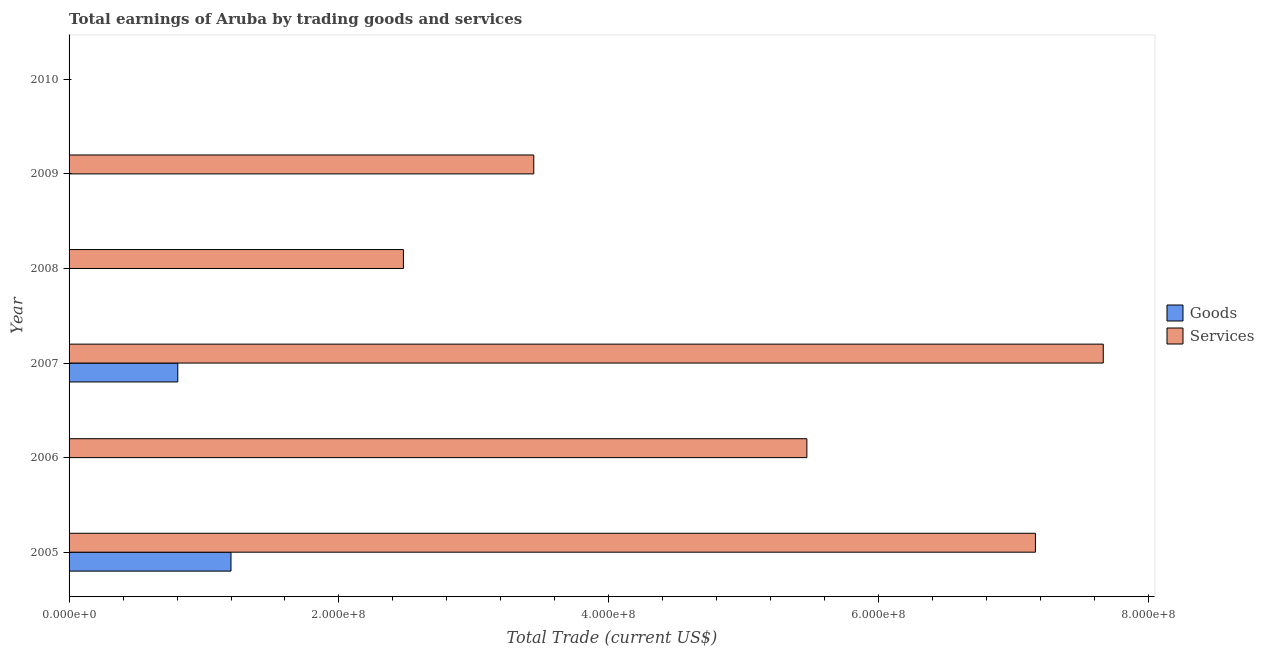Are the number of bars on each tick of the Y-axis equal?
Your answer should be compact. No. How many bars are there on the 1st tick from the bottom?
Your answer should be compact. 2. What is the label of the 4th group of bars from the top?
Your answer should be very brief. 2007. In how many cases, is the number of bars for a given year not equal to the number of legend labels?
Provide a short and direct response. 4. What is the amount earned by trading services in 2008?
Your answer should be compact. 2.48e+08. Across all years, what is the maximum amount earned by trading goods?
Offer a very short reply. 1.20e+08. Across all years, what is the minimum amount earned by trading services?
Your answer should be very brief. 0. What is the total amount earned by trading goods in the graph?
Make the answer very short. 2.01e+08. What is the difference between the amount earned by trading services in 2006 and that in 2009?
Offer a very short reply. 2.02e+08. What is the difference between the amount earned by trading goods in 2009 and the amount earned by trading services in 2006?
Give a very brief answer. -5.47e+08. What is the average amount earned by trading goods per year?
Your answer should be compact. 3.34e+07. In the year 2005, what is the difference between the amount earned by trading goods and amount earned by trading services?
Offer a terse response. -5.96e+08. In how many years, is the amount earned by trading goods greater than 240000000 US$?
Give a very brief answer. 0. What is the ratio of the amount earned by trading services in 2007 to that in 2009?
Provide a succinct answer. 2.23. Is the amount earned by trading services in 2007 less than that in 2008?
Give a very brief answer. No. What is the difference between the highest and the second highest amount earned by trading services?
Offer a very short reply. 5.03e+07. What is the difference between the highest and the lowest amount earned by trading goods?
Provide a short and direct response. 1.20e+08. In how many years, is the amount earned by trading services greater than the average amount earned by trading services taken over all years?
Ensure brevity in your answer.  3. Is the sum of the amount earned by trading services in 2006 and 2008 greater than the maximum amount earned by trading goods across all years?
Your answer should be compact. Yes. How many years are there in the graph?
Keep it short and to the point. 6. Are the values on the major ticks of X-axis written in scientific E-notation?
Provide a short and direct response. Yes. Where does the legend appear in the graph?
Give a very brief answer. Center right. What is the title of the graph?
Give a very brief answer. Total earnings of Aruba by trading goods and services. What is the label or title of the X-axis?
Your answer should be compact. Total Trade (current US$). What is the Total Trade (current US$) in Goods in 2005?
Make the answer very short. 1.20e+08. What is the Total Trade (current US$) of Services in 2005?
Your answer should be compact. 7.16e+08. What is the Total Trade (current US$) in Services in 2006?
Provide a succinct answer. 5.47e+08. What is the Total Trade (current US$) in Goods in 2007?
Your answer should be compact. 8.06e+07. What is the Total Trade (current US$) in Services in 2007?
Your answer should be compact. 7.66e+08. What is the Total Trade (current US$) in Goods in 2008?
Give a very brief answer. 0. What is the Total Trade (current US$) of Services in 2008?
Offer a terse response. 2.48e+08. What is the Total Trade (current US$) of Services in 2009?
Offer a very short reply. 3.44e+08. What is the Total Trade (current US$) of Goods in 2010?
Ensure brevity in your answer.  0. What is the Total Trade (current US$) of Services in 2010?
Offer a very short reply. 0. Across all years, what is the maximum Total Trade (current US$) in Goods?
Give a very brief answer. 1.20e+08. Across all years, what is the maximum Total Trade (current US$) of Services?
Make the answer very short. 7.66e+08. What is the total Total Trade (current US$) in Goods in the graph?
Ensure brevity in your answer.  2.01e+08. What is the total Total Trade (current US$) in Services in the graph?
Provide a succinct answer. 2.62e+09. What is the difference between the Total Trade (current US$) of Services in 2005 and that in 2006?
Make the answer very short. 1.69e+08. What is the difference between the Total Trade (current US$) in Goods in 2005 and that in 2007?
Your response must be concise. 3.94e+07. What is the difference between the Total Trade (current US$) of Services in 2005 and that in 2007?
Your response must be concise. -5.03e+07. What is the difference between the Total Trade (current US$) of Services in 2005 and that in 2008?
Provide a succinct answer. 4.68e+08. What is the difference between the Total Trade (current US$) in Services in 2005 and that in 2009?
Ensure brevity in your answer.  3.72e+08. What is the difference between the Total Trade (current US$) in Services in 2006 and that in 2007?
Provide a short and direct response. -2.20e+08. What is the difference between the Total Trade (current US$) in Services in 2006 and that in 2008?
Your answer should be compact. 2.99e+08. What is the difference between the Total Trade (current US$) in Services in 2006 and that in 2009?
Offer a very short reply. 2.02e+08. What is the difference between the Total Trade (current US$) of Services in 2007 and that in 2008?
Offer a very short reply. 5.19e+08. What is the difference between the Total Trade (current US$) of Services in 2007 and that in 2009?
Make the answer very short. 4.22e+08. What is the difference between the Total Trade (current US$) of Services in 2008 and that in 2009?
Your answer should be very brief. -9.66e+07. What is the difference between the Total Trade (current US$) in Goods in 2005 and the Total Trade (current US$) in Services in 2006?
Keep it short and to the point. -4.27e+08. What is the difference between the Total Trade (current US$) of Goods in 2005 and the Total Trade (current US$) of Services in 2007?
Provide a short and direct response. -6.46e+08. What is the difference between the Total Trade (current US$) of Goods in 2005 and the Total Trade (current US$) of Services in 2008?
Your answer should be very brief. -1.28e+08. What is the difference between the Total Trade (current US$) of Goods in 2005 and the Total Trade (current US$) of Services in 2009?
Provide a succinct answer. -2.24e+08. What is the difference between the Total Trade (current US$) in Goods in 2007 and the Total Trade (current US$) in Services in 2008?
Your answer should be compact. -1.67e+08. What is the difference between the Total Trade (current US$) in Goods in 2007 and the Total Trade (current US$) in Services in 2009?
Ensure brevity in your answer.  -2.64e+08. What is the average Total Trade (current US$) in Goods per year?
Provide a short and direct response. 3.34e+07. What is the average Total Trade (current US$) in Services per year?
Your response must be concise. 4.37e+08. In the year 2005, what is the difference between the Total Trade (current US$) of Goods and Total Trade (current US$) of Services?
Ensure brevity in your answer.  -5.96e+08. In the year 2007, what is the difference between the Total Trade (current US$) of Goods and Total Trade (current US$) of Services?
Your answer should be very brief. -6.86e+08. What is the ratio of the Total Trade (current US$) of Services in 2005 to that in 2006?
Offer a very short reply. 1.31. What is the ratio of the Total Trade (current US$) in Goods in 2005 to that in 2007?
Make the answer very short. 1.49. What is the ratio of the Total Trade (current US$) of Services in 2005 to that in 2007?
Provide a short and direct response. 0.93. What is the ratio of the Total Trade (current US$) in Services in 2005 to that in 2008?
Offer a very short reply. 2.89. What is the ratio of the Total Trade (current US$) of Services in 2005 to that in 2009?
Ensure brevity in your answer.  2.08. What is the ratio of the Total Trade (current US$) in Services in 2006 to that in 2007?
Provide a succinct answer. 0.71. What is the ratio of the Total Trade (current US$) of Services in 2006 to that in 2008?
Provide a short and direct response. 2.21. What is the ratio of the Total Trade (current US$) in Services in 2006 to that in 2009?
Make the answer very short. 1.59. What is the ratio of the Total Trade (current US$) in Services in 2007 to that in 2008?
Your response must be concise. 3.09. What is the ratio of the Total Trade (current US$) in Services in 2007 to that in 2009?
Offer a very short reply. 2.23. What is the ratio of the Total Trade (current US$) in Services in 2008 to that in 2009?
Ensure brevity in your answer.  0.72. What is the difference between the highest and the second highest Total Trade (current US$) of Services?
Make the answer very short. 5.03e+07. What is the difference between the highest and the lowest Total Trade (current US$) of Goods?
Ensure brevity in your answer.  1.20e+08. What is the difference between the highest and the lowest Total Trade (current US$) in Services?
Give a very brief answer. 7.66e+08. 